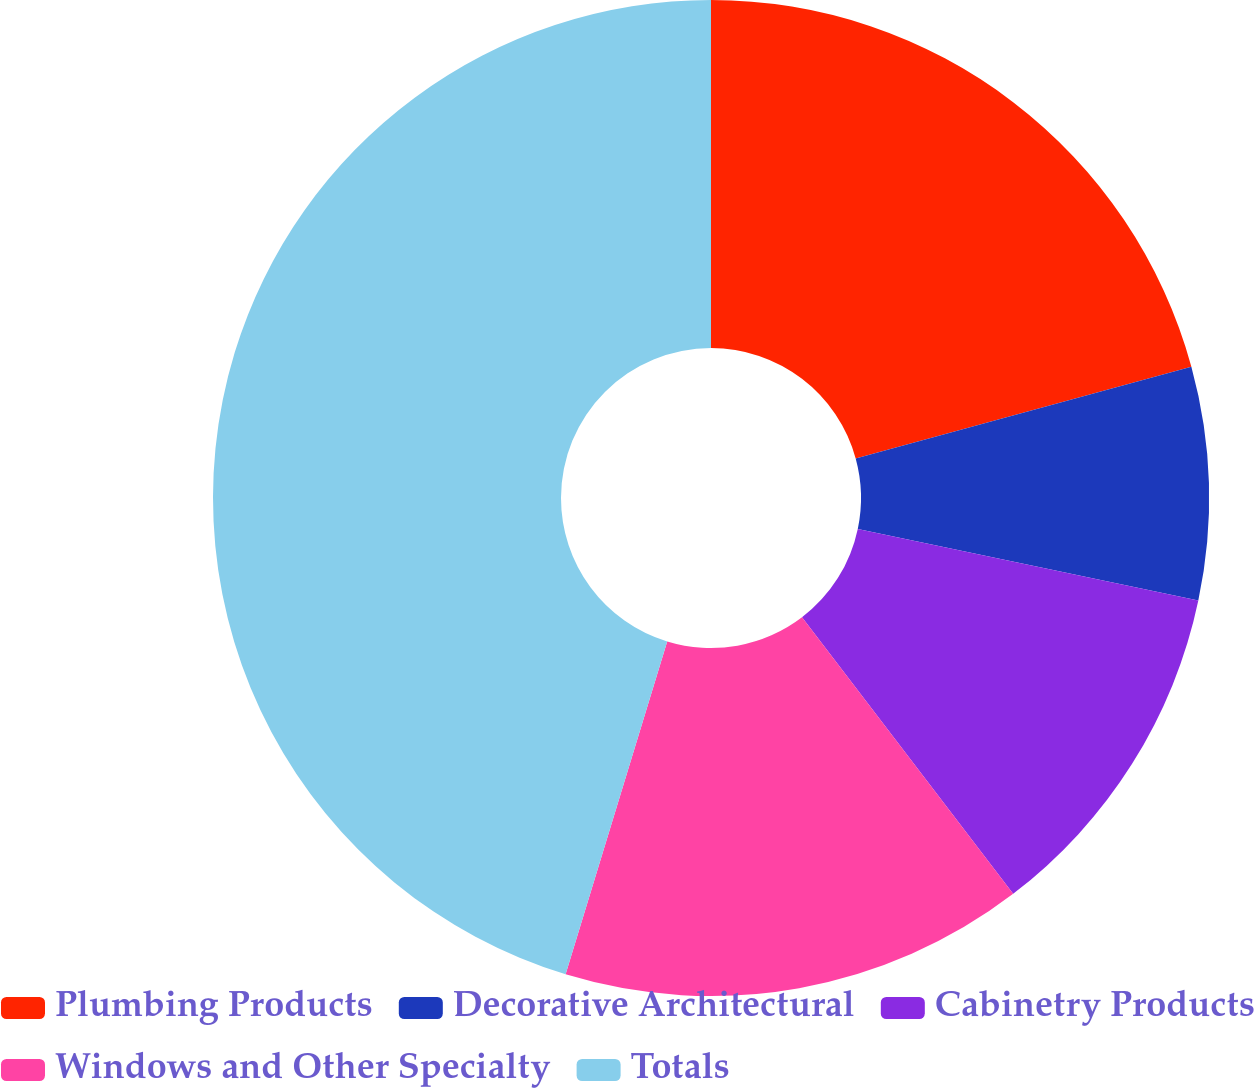Convert chart. <chart><loc_0><loc_0><loc_500><loc_500><pie_chart><fcel>Plumbing Products<fcel>Decorative Architectural<fcel>Cabinetry Products<fcel>Windows and Other Specialty<fcel>Totals<nl><fcel>20.75%<fcel>7.55%<fcel>11.32%<fcel>15.09%<fcel>45.28%<nl></chart> 